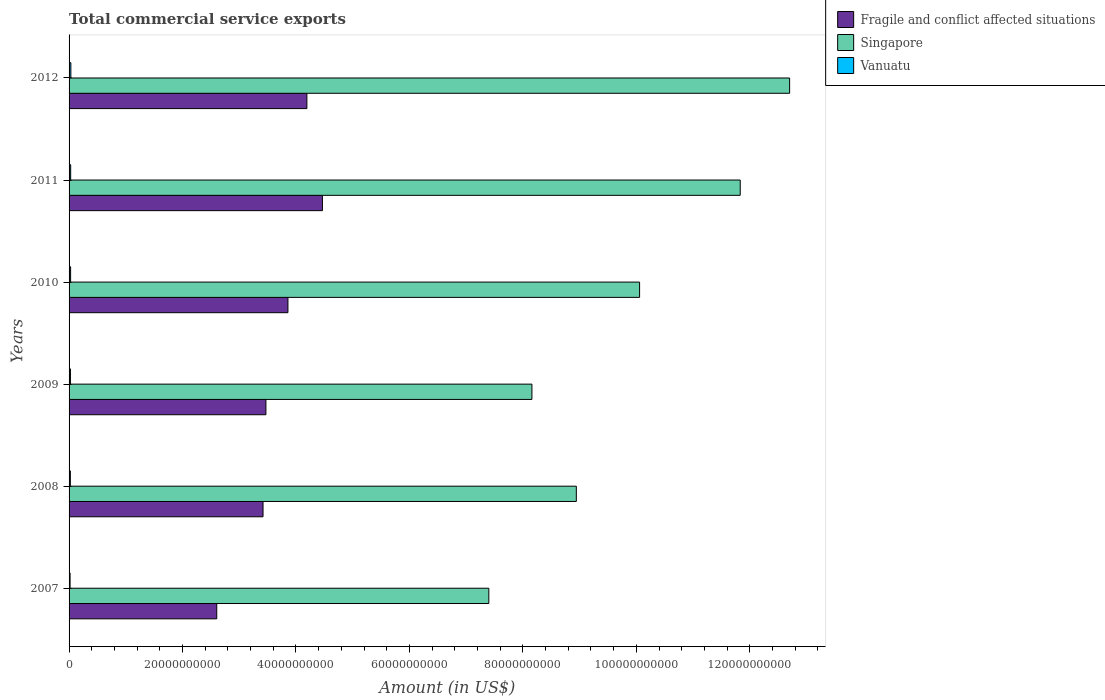How many different coloured bars are there?
Keep it short and to the point. 3. How many groups of bars are there?
Offer a very short reply. 6. How many bars are there on the 6th tick from the bottom?
Provide a short and direct response. 3. What is the label of the 5th group of bars from the top?
Make the answer very short. 2008. What is the total commercial service exports in Vanuatu in 2008?
Keep it short and to the point. 2.25e+08. Across all years, what is the maximum total commercial service exports in Fragile and conflict affected situations?
Your response must be concise. 4.47e+1. Across all years, what is the minimum total commercial service exports in Fragile and conflict affected situations?
Ensure brevity in your answer.  2.60e+1. What is the total total commercial service exports in Vanuatu in the graph?
Your response must be concise. 1.51e+09. What is the difference between the total commercial service exports in Fragile and conflict affected situations in 2007 and that in 2009?
Offer a terse response. -8.67e+09. What is the difference between the total commercial service exports in Vanuatu in 2011 and the total commercial service exports in Singapore in 2008?
Ensure brevity in your answer.  -8.91e+1. What is the average total commercial service exports in Vanuatu per year?
Keep it short and to the point. 2.52e+08. In the year 2011, what is the difference between the total commercial service exports in Fragile and conflict affected situations and total commercial service exports in Singapore?
Keep it short and to the point. -7.36e+1. What is the ratio of the total commercial service exports in Fragile and conflict affected situations in 2007 to that in 2009?
Give a very brief answer. 0.75. Is the total commercial service exports in Vanuatu in 2008 less than that in 2009?
Provide a short and direct response. Yes. What is the difference between the highest and the second highest total commercial service exports in Vanuatu?
Give a very brief answer. 3.38e+07. What is the difference between the highest and the lowest total commercial service exports in Singapore?
Your answer should be very brief. 5.30e+1. In how many years, is the total commercial service exports in Fragile and conflict affected situations greater than the average total commercial service exports in Fragile and conflict affected situations taken over all years?
Keep it short and to the point. 3. What does the 3rd bar from the top in 2007 represents?
Ensure brevity in your answer.  Fragile and conflict affected situations. What does the 3rd bar from the bottom in 2007 represents?
Your response must be concise. Vanuatu. Does the graph contain any zero values?
Your response must be concise. No. How many legend labels are there?
Ensure brevity in your answer.  3. How are the legend labels stacked?
Your response must be concise. Vertical. What is the title of the graph?
Make the answer very short. Total commercial service exports. What is the Amount (in US$) of Fragile and conflict affected situations in 2007?
Your answer should be very brief. 2.60e+1. What is the Amount (in US$) of Singapore in 2007?
Offer a terse response. 7.40e+1. What is the Amount (in US$) in Vanuatu in 2007?
Offer a terse response. 1.77e+08. What is the Amount (in US$) of Fragile and conflict affected situations in 2008?
Give a very brief answer. 3.42e+1. What is the Amount (in US$) of Singapore in 2008?
Provide a short and direct response. 8.94e+1. What is the Amount (in US$) of Vanuatu in 2008?
Keep it short and to the point. 2.25e+08. What is the Amount (in US$) of Fragile and conflict affected situations in 2009?
Ensure brevity in your answer.  3.47e+1. What is the Amount (in US$) in Singapore in 2009?
Provide a short and direct response. 8.16e+1. What is the Amount (in US$) in Vanuatu in 2009?
Your answer should be compact. 2.41e+08. What is the Amount (in US$) in Fragile and conflict affected situations in 2010?
Provide a short and direct response. 3.86e+1. What is the Amount (in US$) in Singapore in 2010?
Your answer should be very brief. 1.01e+11. What is the Amount (in US$) in Vanuatu in 2010?
Provide a succinct answer. 2.71e+08. What is the Amount (in US$) in Fragile and conflict affected situations in 2011?
Provide a succinct answer. 4.47e+1. What is the Amount (in US$) of Singapore in 2011?
Make the answer very short. 1.18e+11. What is the Amount (in US$) in Vanuatu in 2011?
Make the answer very short. 2.81e+08. What is the Amount (in US$) of Fragile and conflict affected situations in 2012?
Offer a terse response. 4.19e+1. What is the Amount (in US$) of Singapore in 2012?
Offer a very short reply. 1.27e+11. What is the Amount (in US$) of Vanuatu in 2012?
Ensure brevity in your answer.  3.15e+08. Across all years, what is the maximum Amount (in US$) in Fragile and conflict affected situations?
Offer a very short reply. 4.47e+1. Across all years, what is the maximum Amount (in US$) of Singapore?
Offer a terse response. 1.27e+11. Across all years, what is the maximum Amount (in US$) in Vanuatu?
Ensure brevity in your answer.  3.15e+08. Across all years, what is the minimum Amount (in US$) in Fragile and conflict affected situations?
Offer a very short reply. 2.60e+1. Across all years, what is the minimum Amount (in US$) of Singapore?
Give a very brief answer. 7.40e+1. Across all years, what is the minimum Amount (in US$) of Vanuatu?
Make the answer very short. 1.77e+08. What is the total Amount (in US$) in Fragile and conflict affected situations in the graph?
Offer a terse response. 2.20e+11. What is the total Amount (in US$) in Singapore in the graph?
Offer a very short reply. 5.91e+11. What is the total Amount (in US$) of Vanuatu in the graph?
Provide a short and direct response. 1.51e+09. What is the difference between the Amount (in US$) of Fragile and conflict affected situations in 2007 and that in 2008?
Your answer should be compact. -8.16e+09. What is the difference between the Amount (in US$) of Singapore in 2007 and that in 2008?
Your answer should be very brief. -1.54e+1. What is the difference between the Amount (in US$) of Vanuatu in 2007 and that in 2008?
Your answer should be very brief. -4.83e+07. What is the difference between the Amount (in US$) of Fragile and conflict affected situations in 2007 and that in 2009?
Make the answer very short. -8.67e+09. What is the difference between the Amount (in US$) of Singapore in 2007 and that in 2009?
Provide a succinct answer. -7.60e+09. What is the difference between the Amount (in US$) in Vanuatu in 2007 and that in 2009?
Your answer should be very brief. -6.40e+07. What is the difference between the Amount (in US$) in Fragile and conflict affected situations in 2007 and that in 2010?
Ensure brevity in your answer.  -1.25e+1. What is the difference between the Amount (in US$) in Singapore in 2007 and that in 2010?
Your answer should be compact. -2.66e+1. What is the difference between the Amount (in US$) in Vanuatu in 2007 and that in 2010?
Your answer should be very brief. -9.42e+07. What is the difference between the Amount (in US$) in Fragile and conflict affected situations in 2007 and that in 2011?
Your answer should be compact. -1.86e+1. What is the difference between the Amount (in US$) of Singapore in 2007 and that in 2011?
Provide a short and direct response. -4.43e+1. What is the difference between the Amount (in US$) in Vanuatu in 2007 and that in 2011?
Ensure brevity in your answer.  -1.04e+08. What is the difference between the Amount (in US$) of Fragile and conflict affected situations in 2007 and that in 2012?
Offer a terse response. -1.59e+1. What is the difference between the Amount (in US$) of Singapore in 2007 and that in 2012?
Your answer should be compact. -5.30e+1. What is the difference between the Amount (in US$) of Vanuatu in 2007 and that in 2012?
Ensure brevity in your answer.  -1.38e+08. What is the difference between the Amount (in US$) of Fragile and conflict affected situations in 2008 and that in 2009?
Offer a terse response. -5.09e+08. What is the difference between the Amount (in US$) of Singapore in 2008 and that in 2009?
Make the answer very short. 7.83e+09. What is the difference between the Amount (in US$) of Vanuatu in 2008 and that in 2009?
Your answer should be compact. -1.57e+07. What is the difference between the Amount (in US$) of Fragile and conflict affected situations in 2008 and that in 2010?
Ensure brevity in your answer.  -4.39e+09. What is the difference between the Amount (in US$) in Singapore in 2008 and that in 2010?
Offer a terse response. -1.12e+1. What is the difference between the Amount (in US$) of Vanuatu in 2008 and that in 2010?
Give a very brief answer. -4.59e+07. What is the difference between the Amount (in US$) of Fragile and conflict affected situations in 2008 and that in 2011?
Offer a very short reply. -1.05e+1. What is the difference between the Amount (in US$) in Singapore in 2008 and that in 2011?
Provide a succinct answer. -2.89e+1. What is the difference between the Amount (in US$) in Vanuatu in 2008 and that in 2011?
Provide a succinct answer. -5.62e+07. What is the difference between the Amount (in US$) in Fragile and conflict affected situations in 2008 and that in 2012?
Your answer should be very brief. -7.73e+09. What is the difference between the Amount (in US$) of Singapore in 2008 and that in 2012?
Your response must be concise. -3.76e+1. What is the difference between the Amount (in US$) in Vanuatu in 2008 and that in 2012?
Make the answer very short. -9.00e+07. What is the difference between the Amount (in US$) in Fragile and conflict affected situations in 2009 and that in 2010?
Your answer should be compact. -3.88e+09. What is the difference between the Amount (in US$) in Singapore in 2009 and that in 2010?
Offer a very short reply. -1.90e+1. What is the difference between the Amount (in US$) of Vanuatu in 2009 and that in 2010?
Your answer should be very brief. -3.02e+07. What is the difference between the Amount (in US$) in Fragile and conflict affected situations in 2009 and that in 2011?
Keep it short and to the point. -9.96e+09. What is the difference between the Amount (in US$) in Singapore in 2009 and that in 2011?
Give a very brief answer. -3.67e+1. What is the difference between the Amount (in US$) in Vanuatu in 2009 and that in 2011?
Provide a succinct answer. -4.05e+07. What is the difference between the Amount (in US$) of Fragile and conflict affected situations in 2009 and that in 2012?
Offer a terse response. -7.22e+09. What is the difference between the Amount (in US$) of Singapore in 2009 and that in 2012?
Your answer should be compact. -4.54e+1. What is the difference between the Amount (in US$) in Vanuatu in 2009 and that in 2012?
Your response must be concise. -7.43e+07. What is the difference between the Amount (in US$) of Fragile and conflict affected situations in 2010 and that in 2011?
Your answer should be very brief. -6.08e+09. What is the difference between the Amount (in US$) in Singapore in 2010 and that in 2011?
Your answer should be very brief. -1.77e+1. What is the difference between the Amount (in US$) in Vanuatu in 2010 and that in 2011?
Provide a succinct answer. -1.03e+07. What is the difference between the Amount (in US$) of Fragile and conflict affected situations in 2010 and that in 2012?
Keep it short and to the point. -3.34e+09. What is the difference between the Amount (in US$) in Singapore in 2010 and that in 2012?
Make the answer very short. -2.64e+1. What is the difference between the Amount (in US$) of Vanuatu in 2010 and that in 2012?
Offer a terse response. -4.41e+07. What is the difference between the Amount (in US$) in Fragile and conflict affected situations in 2011 and that in 2012?
Offer a very short reply. 2.74e+09. What is the difference between the Amount (in US$) of Singapore in 2011 and that in 2012?
Give a very brief answer. -8.71e+09. What is the difference between the Amount (in US$) in Vanuatu in 2011 and that in 2012?
Your answer should be very brief. -3.38e+07. What is the difference between the Amount (in US$) in Fragile and conflict affected situations in 2007 and the Amount (in US$) in Singapore in 2008?
Offer a very short reply. -6.34e+1. What is the difference between the Amount (in US$) of Fragile and conflict affected situations in 2007 and the Amount (in US$) of Vanuatu in 2008?
Provide a short and direct response. 2.58e+1. What is the difference between the Amount (in US$) of Singapore in 2007 and the Amount (in US$) of Vanuatu in 2008?
Provide a short and direct response. 7.38e+1. What is the difference between the Amount (in US$) in Fragile and conflict affected situations in 2007 and the Amount (in US$) in Singapore in 2009?
Ensure brevity in your answer.  -5.56e+1. What is the difference between the Amount (in US$) of Fragile and conflict affected situations in 2007 and the Amount (in US$) of Vanuatu in 2009?
Provide a short and direct response. 2.58e+1. What is the difference between the Amount (in US$) in Singapore in 2007 and the Amount (in US$) in Vanuatu in 2009?
Keep it short and to the point. 7.38e+1. What is the difference between the Amount (in US$) in Fragile and conflict affected situations in 2007 and the Amount (in US$) in Singapore in 2010?
Ensure brevity in your answer.  -7.45e+1. What is the difference between the Amount (in US$) of Fragile and conflict affected situations in 2007 and the Amount (in US$) of Vanuatu in 2010?
Give a very brief answer. 2.58e+1. What is the difference between the Amount (in US$) in Singapore in 2007 and the Amount (in US$) in Vanuatu in 2010?
Keep it short and to the point. 7.37e+1. What is the difference between the Amount (in US$) in Fragile and conflict affected situations in 2007 and the Amount (in US$) in Singapore in 2011?
Your answer should be very brief. -9.23e+1. What is the difference between the Amount (in US$) of Fragile and conflict affected situations in 2007 and the Amount (in US$) of Vanuatu in 2011?
Provide a succinct answer. 2.58e+1. What is the difference between the Amount (in US$) of Singapore in 2007 and the Amount (in US$) of Vanuatu in 2011?
Your response must be concise. 7.37e+1. What is the difference between the Amount (in US$) in Fragile and conflict affected situations in 2007 and the Amount (in US$) in Singapore in 2012?
Your answer should be very brief. -1.01e+11. What is the difference between the Amount (in US$) in Fragile and conflict affected situations in 2007 and the Amount (in US$) in Vanuatu in 2012?
Provide a short and direct response. 2.57e+1. What is the difference between the Amount (in US$) in Singapore in 2007 and the Amount (in US$) in Vanuatu in 2012?
Keep it short and to the point. 7.37e+1. What is the difference between the Amount (in US$) of Fragile and conflict affected situations in 2008 and the Amount (in US$) of Singapore in 2009?
Give a very brief answer. -4.74e+1. What is the difference between the Amount (in US$) of Fragile and conflict affected situations in 2008 and the Amount (in US$) of Vanuatu in 2009?
Keep it short and to the point. 3.40e+1. What is the difference between the Amount (in US$) in Singapore in 2008 and the Amount (in US$) in Vanuatu in 2009?
Keep it short and to the point. 8.92e+1. What is the difference between the Amount (in US$) in Fragile and conflict affected situations in 2008 and the Amount (in US$) in Singapore in 2010?
Offer a very short reply. -6.64e+1. What is the difference between the Amount (in US$) of Fragile and conflict affected situations in 2008 and the Amount (in US$) of Vanuatu in 2010?
Your answer should be very brief. 3.39e+1. What is the difference between the Amount (in US$) in Singapore in 2008 and the Amount (in US$) in Vanuatu in 2010?
Give a very brief answer. 8.91e+1. What is the difference between the Amount (in US$) in Fragile and conflict affected situations in 2008 and the Amount (in US$) in Singapore in 2011?
Provide a succinct answer. -8.41e+1. What is the difference between the Amount (in US$) in Fragile and conflict affected situations in 2008 and the Amount (in US$) in Vanuatu in 2011?
Give a very brief answer. 3.39e+1. What is the difference between the Amount (in US$) in Singapore in 2008 and the Amount (in US$) in Vanuatu in 2011?
Give a very brief answer. 8.91e+1. What is the difference between the Amount (in US$) of Fragile and conflict affected situations in 2008 and the Amount (in US$) of Singapore in 2012?
Provide a succinct answer. -9.28e+1. What is the difference between the Amount (in US$) in Fragile and conflict affected situations in 2008 and the Amount (in US$) in Vanuatu in 2012?
Provide a short and direct response. 3.39e+1. What is the difference between the Amount (in US$) in Singapore in 2008 and the Amount (in US$) in Vanuatu in 2012?
Provide a succinct answer. 8.91e+1. What is the difference between the Amount (in US$) of Fragile and conflict affected situations in 2009 and the Amount (in US$) of Singapore in 2010?
Keep it short and to the point. -6.59e+1. What is the difference between the Amount (in US$) of Fragile and conflict affected situations in 2009 and the Amount (in US$) of Vanuatu in 2010?
Your answer should be very brief. 3.44e+1. What is the difference between the Amount (in US$) in Singapore in 2009 and the Amount (in US$) in Vanuatu in 2010?
Your response must be concise. 8.13e+1. What is the difference between the Amount (in US$) of Fragile and conflict affected situations in 2009 and the Amount (in US$) of Singapore in 2011?
Provide a short and direct response. -8.36e+1. What is the difference between the Amount (in US$) of Fragile and conflict affected situations in 2009 and the Amount (in US$) of Vanuatu in 2011?
Provide a short and direct response. 3.44e+1. What is the difference between the Amount (in US$) in Singapore in 2009 and the Amount (in US$) in Vanuatu in 2011?
Offer a very short reply. 8.13e+1. What is the difference between the Amount (in US$) of Fragile and conflict affected situations in 2009 and the Amount (in US$) of Singapore in 2012?
Make the answer very short. -9.23e+1. What is the difference between the Amount (in US$) in Fragile and conflict affected situations in 2009 and the Amount (in US$) in Vanuatu in 2012?
Offer a very short reply. 3.44e+1. What is the difference between the Amount (in US$) in Singapore in 2009 and the Amount (in US$) in Vanuatu in 2012?
Provide a short and direct response. 8.13e+1. What is the difference between the Amount (in US$) in Fragile and conflict affected situations in 2010 and the Amount (in US$) in Singapore in 2011?
Provide a succinct answer. -7.97e+1. What is the difference between the Amount (in US$) in Fragile and conflict affected situations in 2010 and the Amount (in US$) in Vanuatu in 2011?
Provide a succinct answer. 3.83e+1. What is the difference between the Amount (in US$) in Singapore in 2010 and the Amount (in US$) in Vanuatu in 2011?
Provide a succinct answer. 1.00e+11. What is the difference between the Amount (in US$) of Fragile and conflict affected situations in 2010 and the Amount (in US$) of Singapore in 2012?
Your response must be concise. -8.84e+1. What is the difference between the Amount (in US$) in Fragile and conflict affected situations in 2010 and the Amount (in US$) in Vanuatu in 2012?
Ensure brevity in your answer.  3.83e+1. What is the difference between the Amount (in US$) of Singapore in 2010 and the Amount (in US$) of Vanuatu in 2012?
Give a very brief answer. 1.00e+11. What is the difference between the Amount (in US$) of Fragile and conflict affected situations in 2011 and the Amount (in US$) of Singapore in 2012?
Provide a short and direct response. -8.24e+1. What is the difference between the Amount (in US$) in Fragile and conflict affected situations in 2011 and the Amount (in US$) in Vanuatu in 2012?
Keep it short and to the point. 4.43e+1. What is the difference between the Amount (in US$) of Singapore in 2011 and the Amount (in US$) of Vanuatu in 2012?
Give a very brief answer. 1.18e+11. What is the average Amount (in US$) of Fragile and conflict affected situations per year?
Offer a terse response. 3.67e+1. What is the average Amount (in US$) of Singapore per year?
Provide a short and direct response. 9.85e+1. What is the average Amount (in US$) in Vanuatu per year?
Your answer should be very brief. 2.52e+08. In the year 2007, what is the difference between the Amount (in US$) of Fragile and conflict affected situations and Amount (in US$) of Singapore?
Ensure brevity in your answer.  -4.80e+1. In the year 2007, what is the difference between the Amount (in US$) in Fragile and conflict affected situations and Amount (in US$) in Vanuatu?
Give a very brief answer. 2.59e+1. In the year 2007, what is the difference between the Amount (in US$) in Singapore and Amount (in US$) in Vanuatu?
Keep it short and to the point. 7.38e+1. In the year 2008, what is the difference between the Amount (in US$) in Fragile and conflict affected situations and Amount (in US$) in Singapore?
Your answer should be very brief. -5.52e+1. In the year 2008, what is the difference between the Amount (in US$) in Fragile and conflict affected situations and Amount (in US$) in Vanuatu?
Your answer should be very brief. 3.40e+1. In the year 2008, what is the difference between the Amount (in US$) in Singapore and Amount (in US$) in Vanuatu?
Your response must be concise. 8.92e+1. In the year 2009, what is the difference between the Amount (in US$) of Fragile and conflict affected situations and Amount (in US$) of Singapore?
Your response must be concise. -4.69e+1. In the year 2009, what is the difference between the Amount (in US$) of Fragile and conflict affected situations and Amount (in US$) of Vanuatu?
Your answer should be very brief. 3.45e+1. In the year 2009, what is the difference between the Amount (in US$) of Singapore and Amount (in US$) of Vanuatu?
Ensure brevity in your answer.  8.14e+1. In the year 2010, what is the difference between the Amount (in US$) in Fragile and conflict affected situations and Amount (in US$) in Singapore?
Provide a succinct answer. -6.20e+1. In the year 2010, what is the difference between the Amount (in US$) of Fragile and conflict affected situations and Amount (in US$) of Vanuatu?
Provide a short and direct response. 3.83e+1. In the year 2010, what is the difference between the Amount (in US$) in Singapore and Amount (in US$) in Vanuatu?
Offer a terse response. 1.00e+11. In the year 2011, what is the difference between the Amount (in US$) of Fragile and conflict affected situations and Amount (in US$) of Singapore?
Your answer should be compact. -7.36e+1. In the year 2011, what is the difference between the Amount (in US$) in Fragile and conflict affected situations and Amount (in US$) in Vanuatu?
Provide a succinct answer. 4.44e+1. In the year 2011, what is the difference between the Amount (in US$) in Singapore and Amount (in US$) in Vanuatu?
Your answer should be compact. 1.18e+11. In the year 2012, what is the difference between the Amount (in US$) in Fragile and conflict affected situations and Amount (in US$) in Singapore?
Your response must be concise. -8.51e+1. In the year 2012, what is the difference between the Amount (in US$) of Fragile and conflict affected situations and Amount (in US$) of Vanuatu?
Your answer should be very brief. 4.16e+1. In the year 2012, what is the difference between the Amount (in US$) in Singapore and Amount (in US$) in Vanuatu?
Give a very brief answer. 1.27e+11. What is the ratio of the Amount (in US$) of Fragile and conflict affected situations in 2007 to that in 2008?
Your response must be concise. 0.76. What is the ratio of the Amount (in US$) of Singapore in 2007 to that in 2008?
Provide a short and direct response. 0.83. What is the ratio of the Amount (in US$) of Vanuatu in 2007 to that in 2008?
Your answer should be compact. 0.79. What is the ratio of the Amount (in US$) in Fragile and conflict affected situations in 2007 to that in 2009?
Give a very brief answer. 0.75. What is the ratio of the Amount (in US$) in Singapore in 2007 to that in 2009?
Offer a terse response. 0.91. What is the ratio of the Amount (in US$) in Vanuatu in 2007 to that in 2009?
Offer a very short reply. 0.73. What is the ratio of the Amount (in US$) of Fragile and conflict affected situations in 2007 to that in 2010?
Your answer should be very brief. 0.67. What is the ratio of the Amount (in US$) of Singapore in 2007 to that in 2010?
Your answer should be compact. 0.74. What is the ratio of the Amount (in US$) in Vanuatu in 2007 to that in 2010?
Your answer should be very brief. 0.65. What is the ratio of the Amount (in US$) of Fragile and conflict affected situations in 2007 to that in 2011?
Keep it short and to the point. 0.58. What is the ratio of the Amount (in US$) of Singapore in 2007 to that in 2011?
Give a very brief answer. 0.63. What is the ratio of the Amount (in US$) of Vanuatu in 2007 to that in 2011?
Ensure brevity in your answer.  0.63. What is the ratio of the Amount (in US$) of Fragile and conflict affected situations in 2007 to that in 2012?
Give a very brief answer. 0.62. What is the ratio of the Amount (in US$) of Singapore in 2007 to that in 2012?
Make the answer very short. 0.58. What is the ratio of the Amount (in US$) of Vanuatu in 2007 to that in 2012?
Give a very brief answer. 0.56. What is the ratio of the Amount (in US$) in Fragile and conflict affected situations in 2008 to that in 2009?
Offer a very short reply. 0.99. What is the ratio of the Amount (in US$) of Singapore in 2008 to that in 2009?
Give a very brief answer. 1.1. What is the ratio of the Amount (in US$) of Vanuatu in 2008 to that in 2009?
Your answer should be compact. 0.93. What is the ratio of the Amount (in US$) in Fragile and conflict affected situations in 2008 to that in 2010?
Provide a short and direct response. 0.89. What is the ratio of the Amount (in US$) of Singapore in 2008 to that in 2010?
Your response must be concise. 0.89. What is the ratio of the Amount (in US$) of Vanuatu in 2008 to that in 2010?
Your response must be concise. 0.83. What is the ratio of the Amount (in US$) in Fragile and conflict affected situations in 2008 to that in 2011?
Keep it short and to the point. 0.77. What is the ratio of the Amount (in US$) in Singapore in 2008 to that in 2011?
Give a very brief answer. 0.76. What is the ratio of the Amount (in US$) of Vanuatu in 2008 to that in 2011?
Provide a short and direct response. 0.8. What is the ratio of the Amount (in US$) in Fragile and conflict affected situations in 2008 to that in 2012?
Offer a very short reply. 0.82. What is the ratio of the Amount (in US$) of Singapore in 2008 to that in 2012?
Your answer should be very brief. 0.7. What is the ratio of the Amount (in US$) of Vanuatu in 2008 to that in 2012?
Make the answer very short. 0.71. What is the ratio of the Amount (in US$) of Fragile and conflict affected situations in 2009 to that in 2010?
Provide a short and direct response. 0.9. What is the ratio of the Amount (in US$) of Singapore in 2009 to that in 2010?
Keep it short and to the point. 0.81. What is the ratio of the Amount (in US$) of Vanuatu in 2009 to that in 2010?
Provide a short and direct response. 0.89. What is the ratio of the Amount (in US$) in Fragile and conflict affected situations in 2009 to that in 2011?
Give a very brief answer. 0.78. What is the ratio of the Amount (in US$) of Singapore in 2009 to that in 2011?
Offer a terse response. 0.69. What is the ratio of the Amount (in US$) in Vanuatu in 2009 to that in 2011?
Offer a terse response. 0.86. What is the ratio of the Amount (in US$) of Fragile and conflict affected situations in 2009 to that in 2012?
Your answer should be compact. 0.83. What is the ratio of the Amount (in US$) in Singapore in 2009 to that in 2012?
Ensure brevity in your answer.  0.64. What is the ratio of the Amount (in US$) of Vanuatu in 2009 to that in 2012?
Your answer should be very brief. 0.76. What is the ratio of the Amount (in US$) of Fragile and conflict affected situations in 2010 to that in 2011?
Your answer should be very brief. 0.86. What is the ratio of the Amount (in US$) of Singapore in 2010 to that in 2011?
Your response must be concise. 0.85. What is the ratio of the Amount (in US$) of Vanuatu in 2010 to that in 2011?
Provide a succinct answer. 0.96. What is the ratio of the Amount (in US$) in Fragile and conflict affected situations in 2010 to that in 2012?
Your response must be concise. 0.92. What is the ratio of the Amount (in US$) of Singapore in 2010 to that in 2012?
Provide a short and direct response. 0.79. What is the ratio of the Amount (in US$) of Vanuatu in 2010 to that in 2012?
Ensure brevity in your answer.  0.86. What is the ratio of the Amount (in US$) of Fragile and conflict affected situations in 2011 to that in 2012?
Keep it short and to the point. 1.07. What is the ratio of the Amount (in US$) in Singapore in 2011 to that in 2012?
Keep it short and to the point. 0.93. What is the ratio of the Amount (in US$) in Vanuatu in 2011 to that in 2012?
Provide a succinct answer. 0.89. What is the difference between the highest and the second highest Amount (in US$) of Fragile and conflict affected situations?
Your answer should be very brief. 2.74e+09. What is the difference between the highest and the second highest Amount (in US$) in Singapore?
Offer a terse response. 8.71e+09. What is the difference between the highest and the second highest Amount (in US$) of Vanuatu?
Give a very brief answer. 3.38e+07. What is the difference between the highest and the lowest Amount (in US$) in Fragile and conflict affected situations?
Provide a succinct answer. 1.86e+1. What is the difference between the highest and the lowest Amount (in US$) of Singapore?
Make the answer very short. 5.30e+1. What is the difference between the highest and the lowest Amount (in US$) in Vanuatu?
Provide a succinct answer. 1.38e+08. 